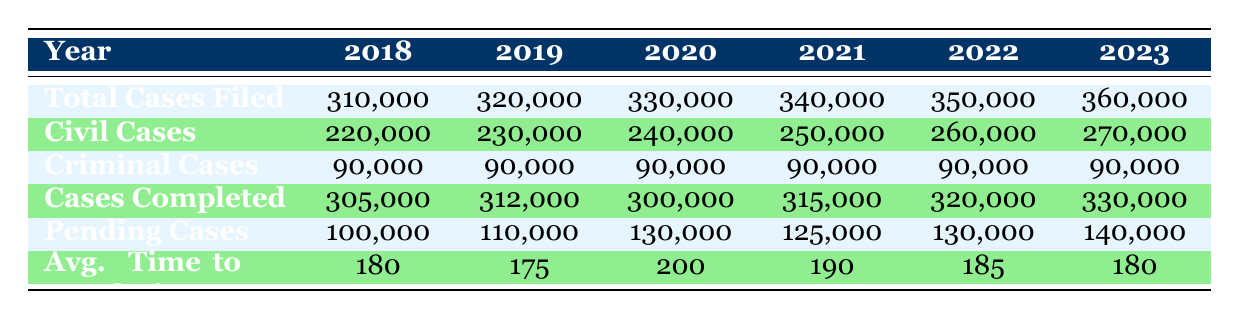What was the total number of cases filed in 2020? The total cases filed in 2020 can be found directly in the table, where it states that 330,000 cases were filed.
Answer: 330,000 In which year did the number of pending cases reach its highest point? By comparing the values for pending cases across all years, we see that 140,000 was the highest in 2023.
Answer: 2023 What is the average number of civil cases filed from 2018 to 2023? To calculate the average civil cases, sum the civil cases for each year: 220,000 + 230,000 + 240,000 + 250,000 + 260,000 + 270,000 = 1,470,000. Then divide by 6, which gives us 1,470,000 / 6 = 245,000.
Answer: 245,000 Did the number of criminal cases filed change from 2018 to 2023? The table indicates that the number of criminal cases remained constant at 90,000 throughout the years from 2018 to 2023.
Answer: No What percentage increase in civil cases filed occurred from 2018 to 2023? The increase in civil cases from 2018 to 2023 is calculated as (270,000 - 220,000) / 220,000 * 100%, which equals (50,000 / 220,000) * 100% = approximately 22.73%.
Answer: Approximately 22.73% How many more cases were completed in 2022 compared to 2020? To find the difference in completed cases between 2022 and 2020, we subtract: 320,000 (2022) - 300,000 (2020) = 20,000.
Answer: 20,000 What was the average time to resolution in days from 2019 to 2021? The time to resolution for those years is 175 days (2019), 200 days (2020), and 190 days (2021). The average is calculated as (175 + 200 + 190) / 3 = 565 / 3 = approximately 188.33 days.
Answer: Approximately 188.33 days Is it true that the total cases filed grew every year from 2018 to 2023? By analyzing the data, we see that the number of total cases filed increased each year from 2018 (310,000) to 2023 (360,000).
Answer: Yes 